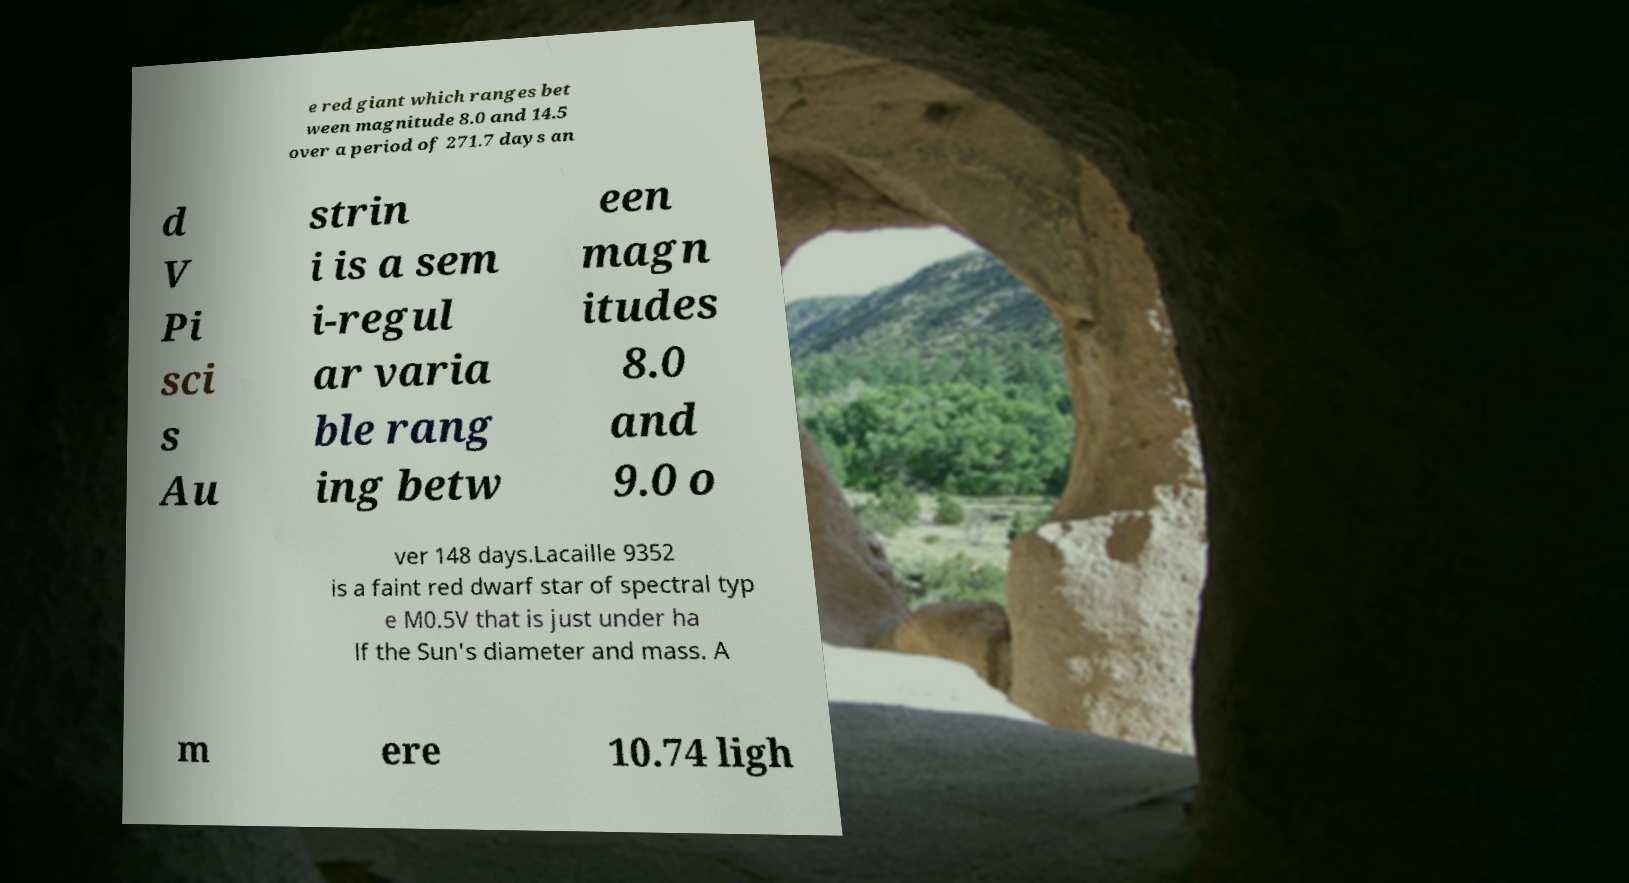Please read and relay the text visible in this image. What does it say? e red giant which ranges bet ween magnitude 8.0 and 14.5 over a period of 271.7 days an d V Pi sci s Au strin i is a sem i-regul ar varia ble rang ing betw een magn itudes 8.0 and 9.0 o ver 148 days.Lacaille 9352 is a faint red dwarf star of spectral typ e M0.5V that is just under ha lf the Sun's diameter and mass. A m ere 10.74 ligh 